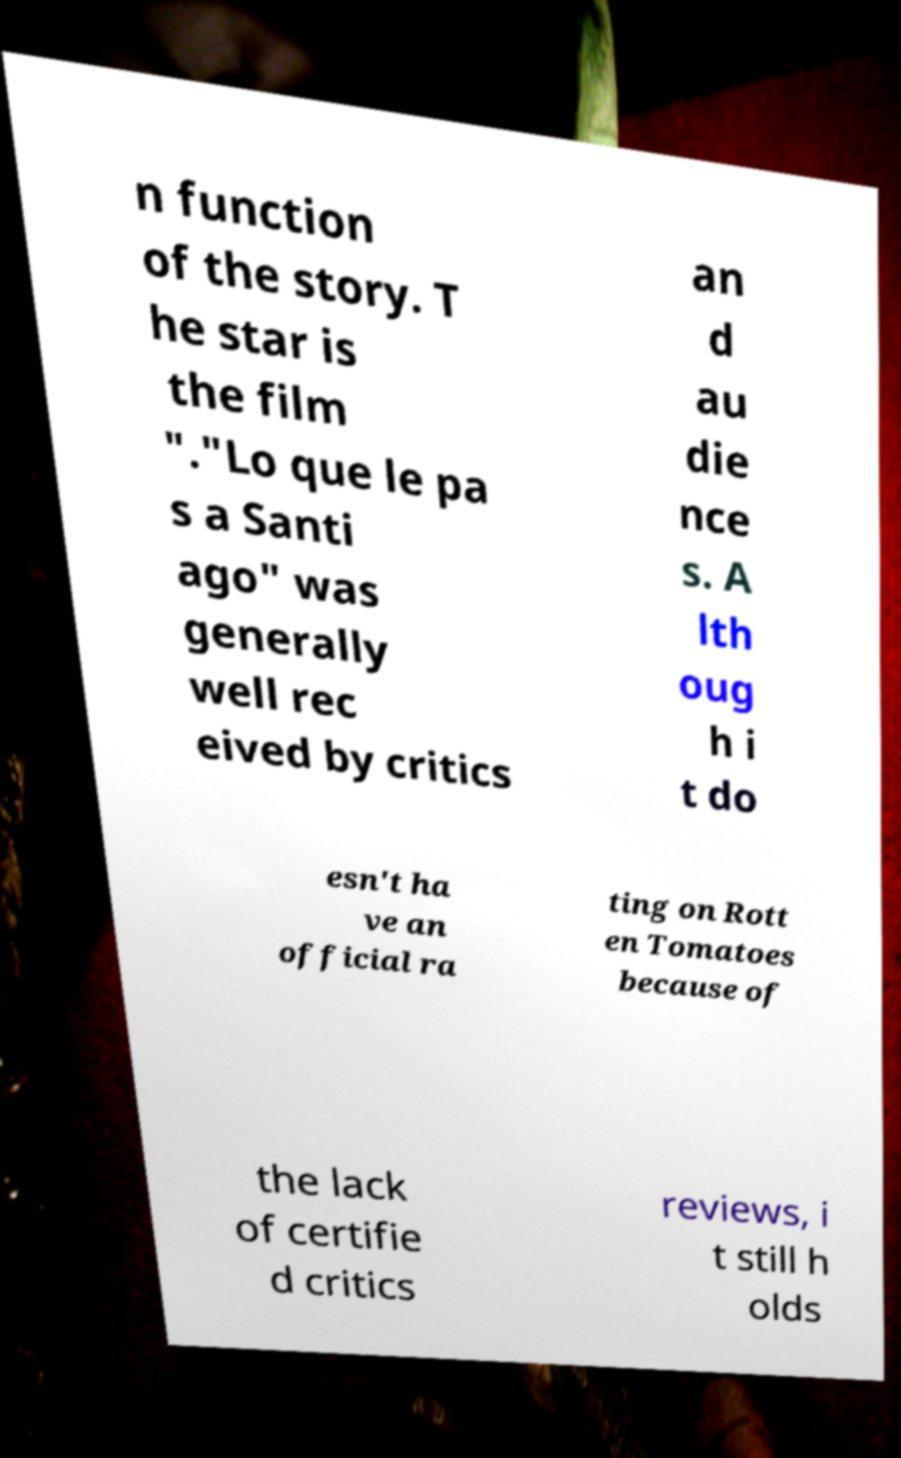For documentation purposes, I need the text within this image transcribed. Could you provide that? n function of the story. T he star is the film "."Lo que le pa s a Santi ago" was generally well rec eived by critics an d au die nce s. A lth oug h i t do esn't ha ve an official ra ting on Rott en Tomatoes because of the lack of certifie d critics reviews, i t still h olds 